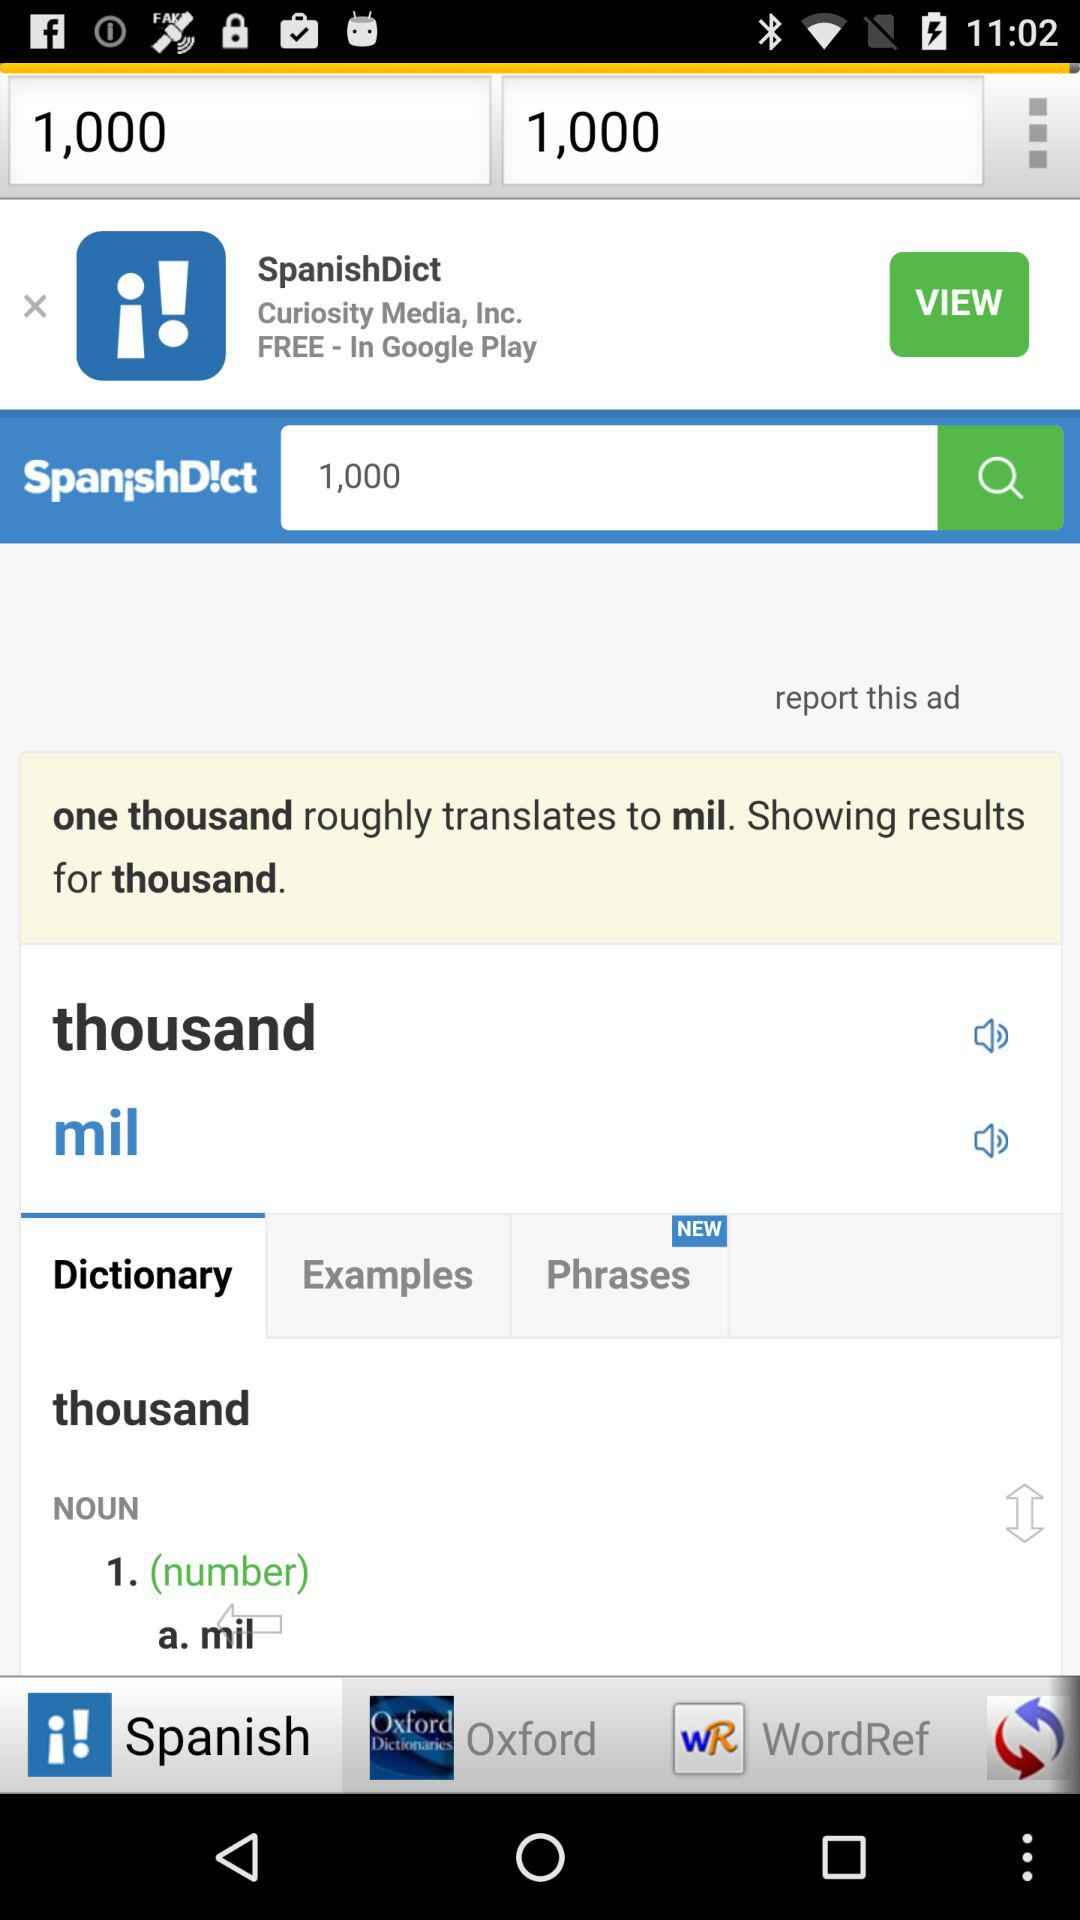Which word does the user want to translate? The user wants to translate the word "one thousand". 